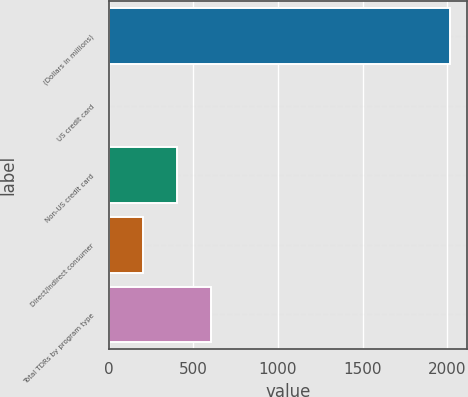Convert chart. <chart><loc_0><loc_0><loc_500><loc_500><bar_chart><fcel>(Dollars in millions)<fcel>US credit card<fcel>Non-US credit card<fcel>Direct/Indirect consumer<fcel>Total TDRs by program type<nl><fcel>2016<fcel>1<fcel>404<fcel>202.5<fcel>605.5<nl></chart> 